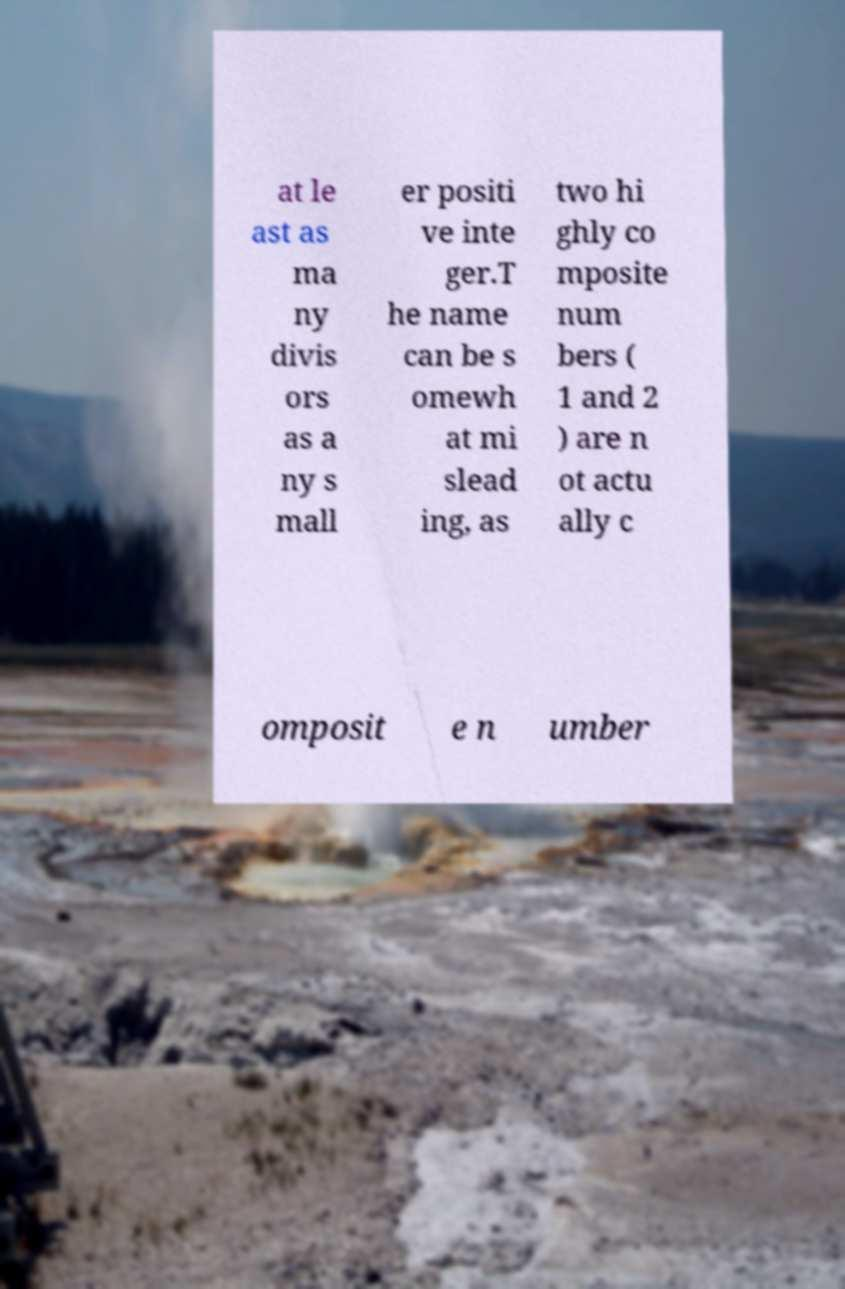Please identify and transcribe the text found in this image. at le ast as ma ny divis ors as a ny s mall er positi ve inte ger.T he name can be s omewh at mi slead ing, as two hi ghly co mposite num bers ( 1 and 2 ) are n ot actu ally c omposit e n umber 